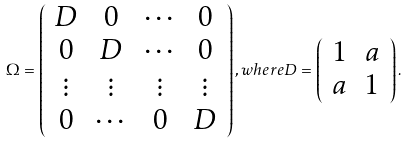Convert formula to latex. <formula><loc_0><loc_0><loc_500><loc_500>\Omega = \left ( \begin{array} { c c c c } D & 0 & \cdots & 0 \\ 0 & D & \cdots & 0 \\ \vdots & \vdots & \vdots & \vdots \\ 0 & \cdots & 0 & D \\ \end{array} \right ) , w h e r e D = \left ( \begin{array} { c c } 1 & a \\ a & 1 \end{array} \right ) .</formula> 